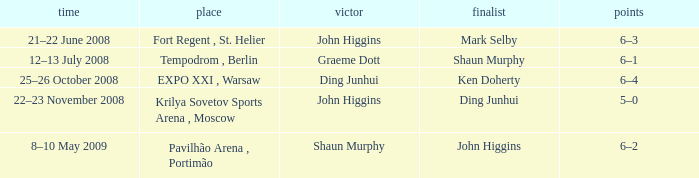When was the match that had Shaun Murphy as runner-up? 12–13 July 2008. 